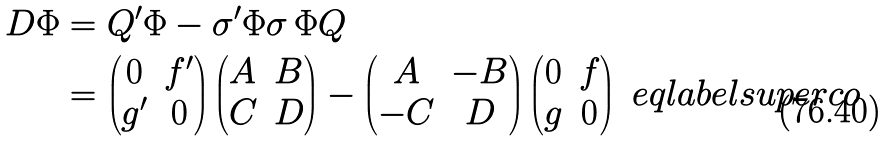Convert formula to latex. <formula><loc_0><loc_0><loc_500><loc_500>D \Phi & = Q ^ { \prime } \Phi - \sigma ^ { \prime } \Phi \sigma \, \Phi Q \\ & = \begin{pmatrix} 0 & f ^ { \prime } \\ g ^ { \prime } & 0 \end{pmatrix} \begin{pmatrix} A & B \\ C & D \end{pmatrix} - \begin{pmatrix} A & - B \\ - C & D \end{pmatrix} \begin{pmatrix} 0 & f \\ g & 0 \end{pmatrix} \ e q l a b e l { s u p e r c o }</formula> 